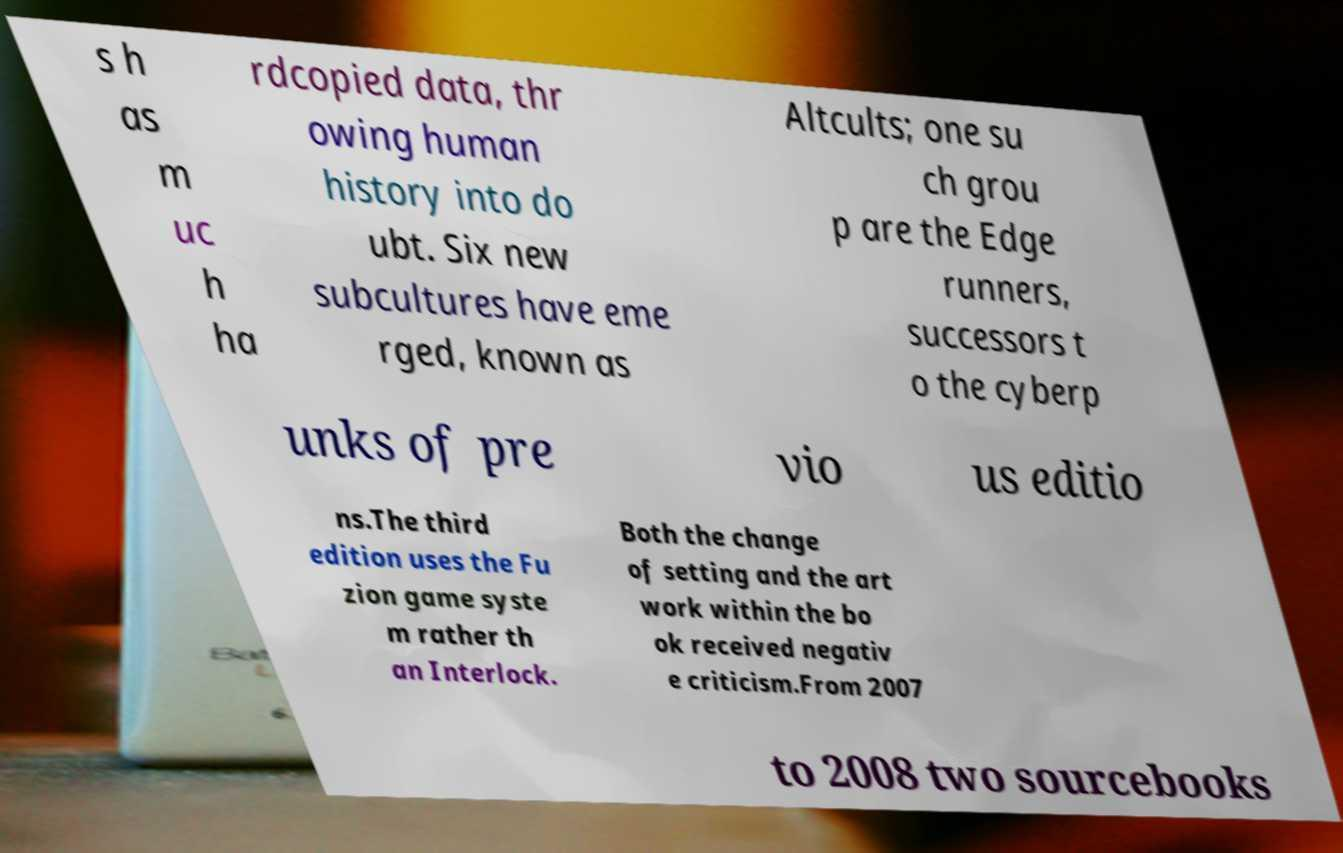Could you assist in decoding the text presented in this image and type it out clearly? s h as m uc h ha rdcopied data, thr owing human history into do ubt. Six new subcultures have eme rged, known as Altcults; one su ch grou p are the Edge runners, successors t o the cyberp unks of pre vio us editio ns.The third edition uses the Fu zion game syste m rather th an Interlock. Both the change of setting and the art work within the bo ok received negativ e criticism.From 2007 to 2008 two sourcebooks 